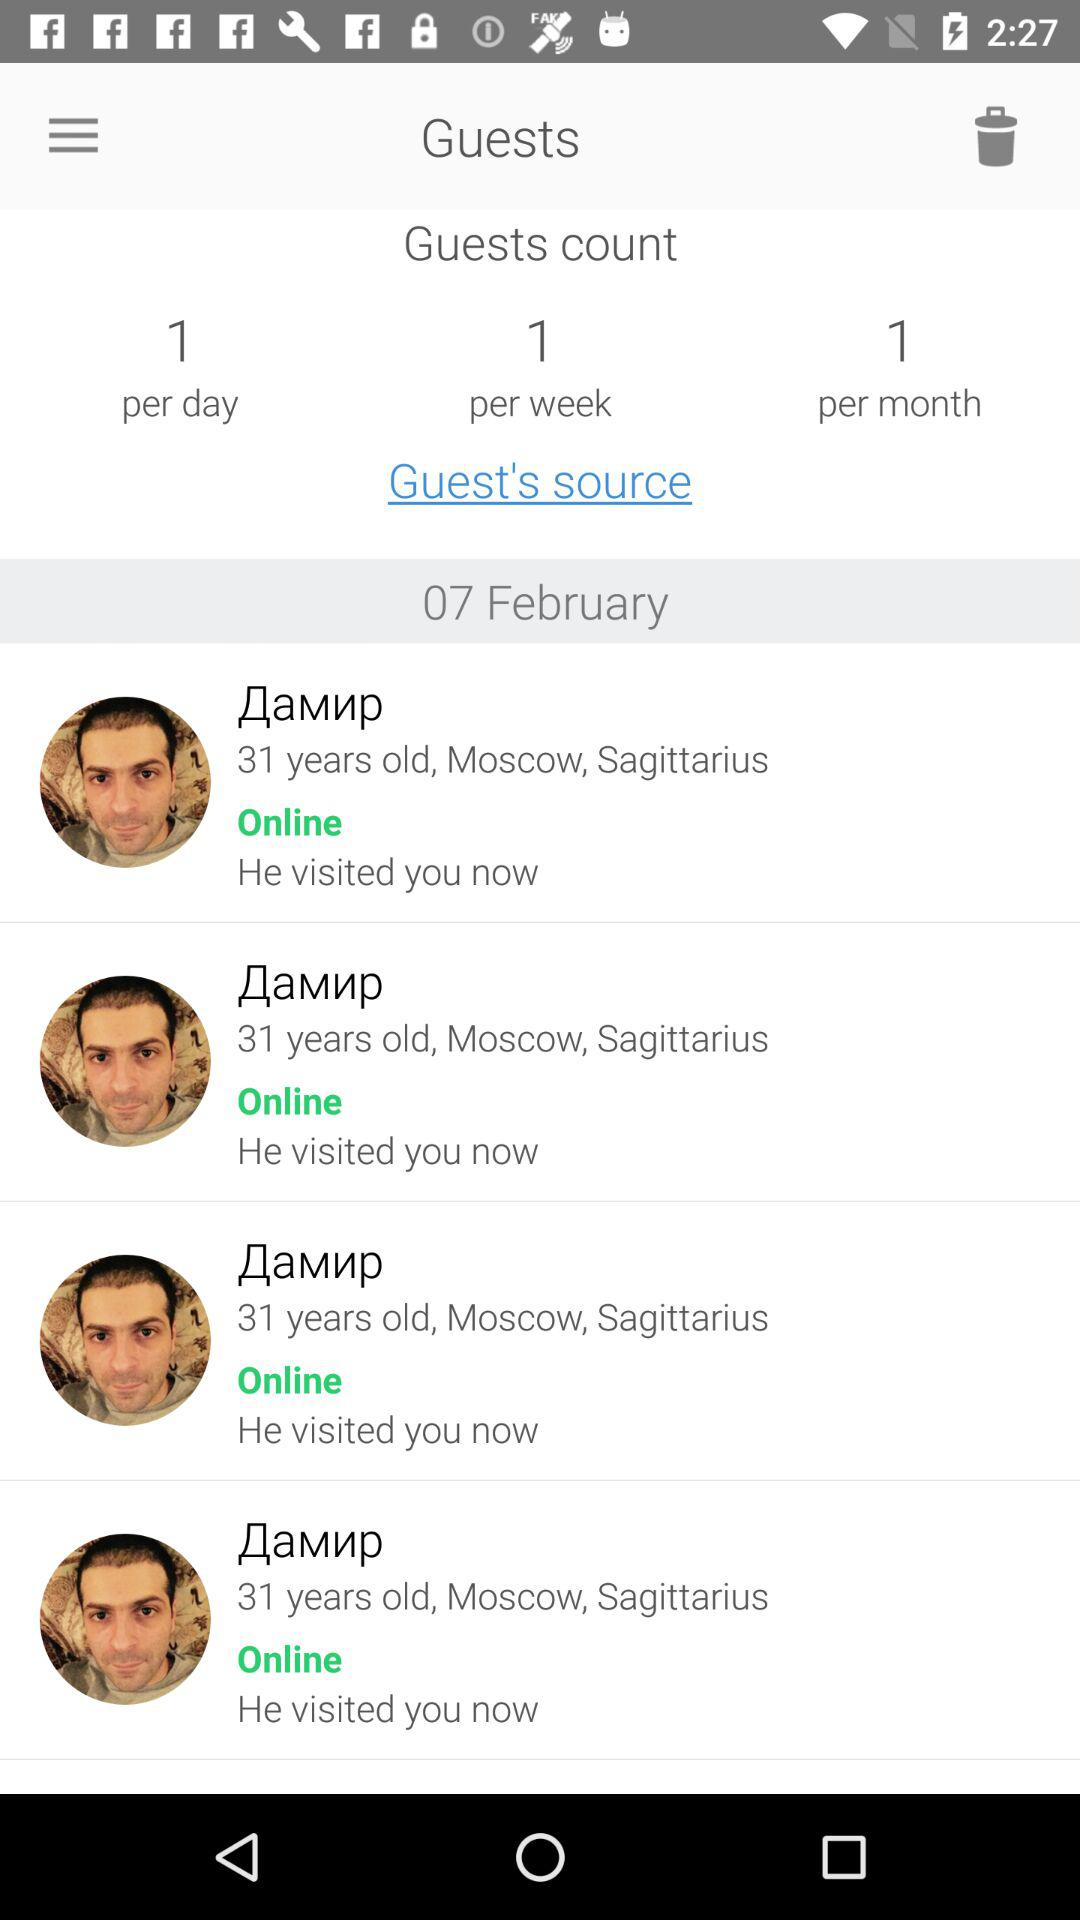How old is the guest? The guest is 31 years old. 